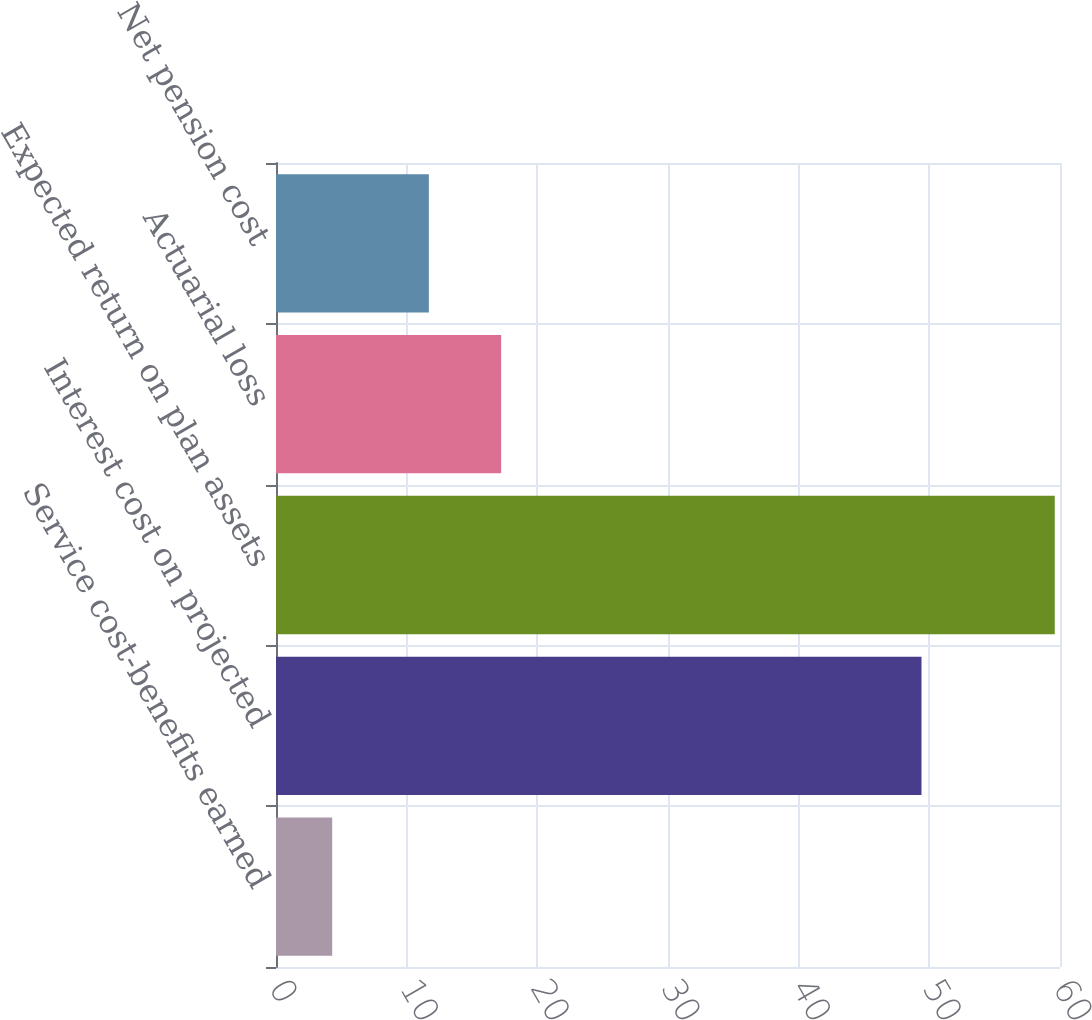Convert chart. <chart><loc_0><loc_0><loc_500><loc_500><bar_chart><fcel>Service cost-benefits earned<fcel>Interest cost on projected<fcel>Expected return on plan assets<fcel>Actuarial loss<fcel>Net pension cost<nl><fcel>4.3<fcel>49.4<fcel>59.6<fcel>17.23<fcel>11.7<nl></chart> 